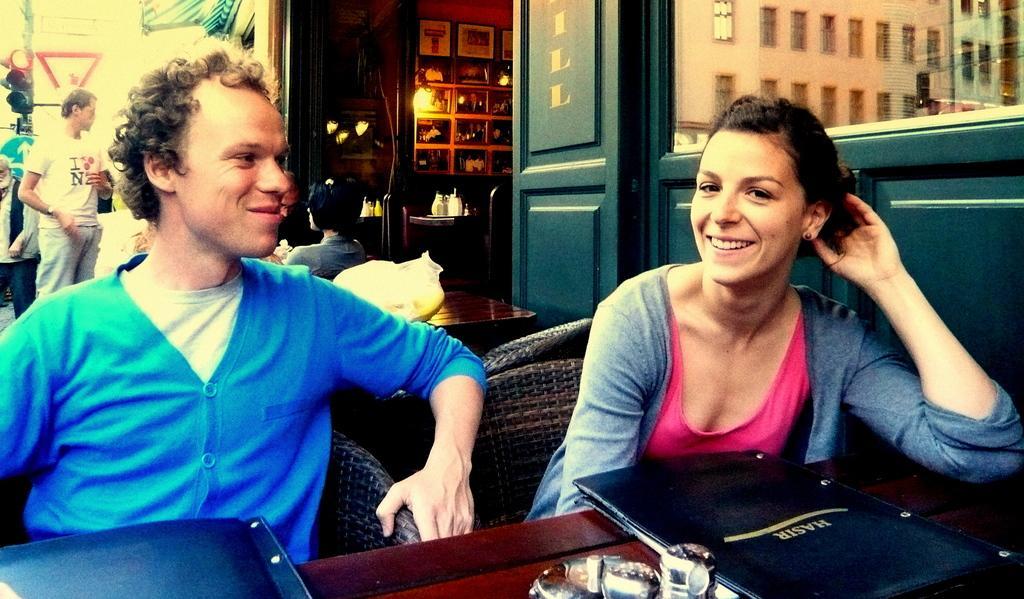Could you give a brief overview of what you see in this image? Here we can see that the two people are sitting on the chair and smiling,and in front here is the table and some objects on it, and at back there is the wall and photo frames on it, and her is the light, here is the traffic signal. 